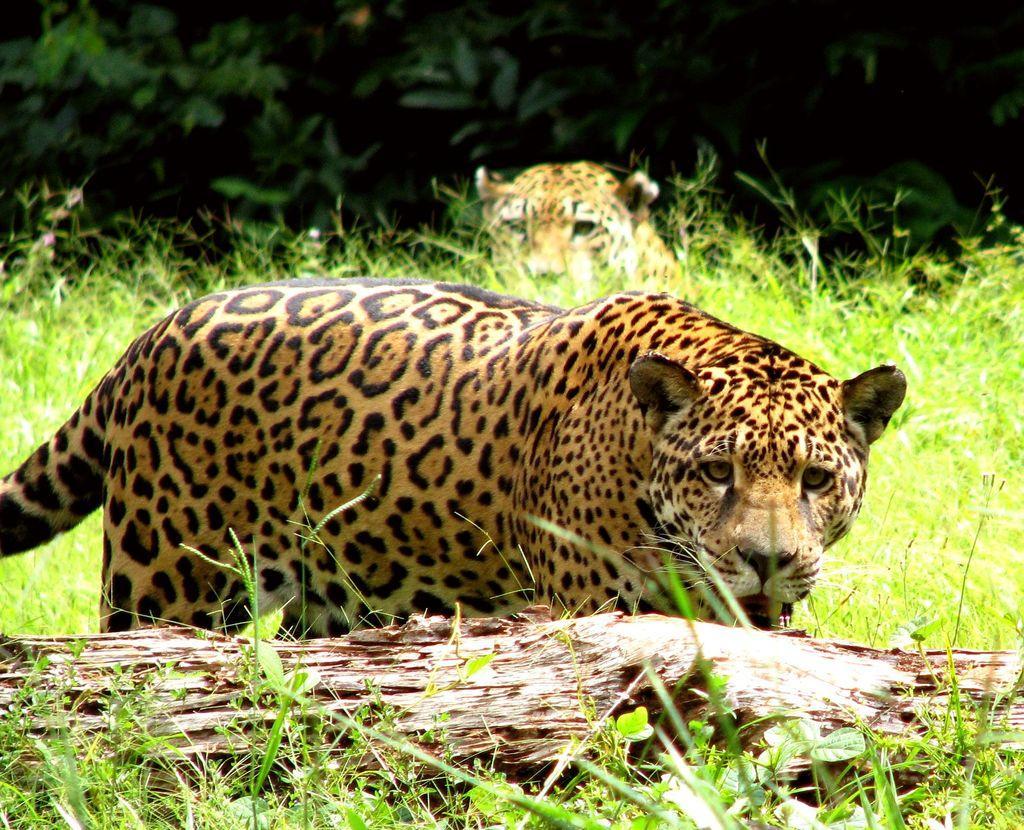Can you describe this image briefly? In the background we can see green leaves. In this picture we can see leopards, grass, plants and a branch. 